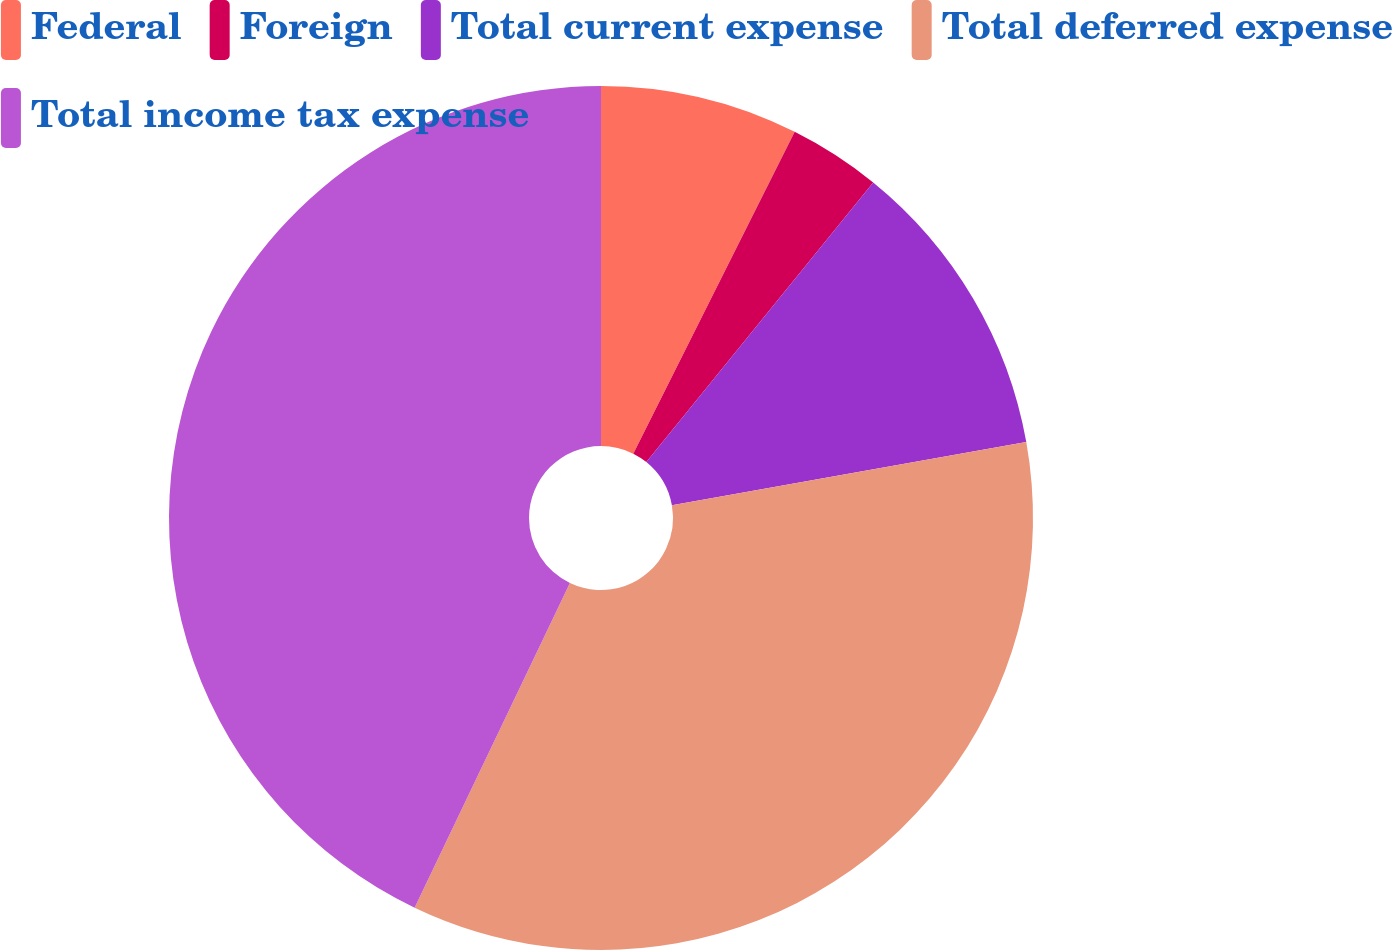Convert chart to OTSL. <chart><loc_0><loc_0><loc_500><loc_500><pie_chart><fcel>Federal<fcel>Foreign<fcel>Total current expense<fcel>Total deferred expense<fcel>Total income tax expense<nl><fcel>7.4%<fcel>3.45%<fcel>11.34%<fcel>34.91%<fcel>42.9%<nl></chart> 